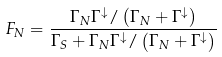Convert formula to latex. <formula><loc_0><loc_0><loc_500><loc_500>F _ { N } = \frac { \Gamma _ { N } \Gamma ^ { \downarrow } / \left ( \Gamma _ { N } + \Gamma ^ { \downarrow } \right ) } { \Gamma _ { S } + \Gamma _ { N } \Gamma ^ { \downarrow } / \left ( \Gamma _ { N } + \Gamma ^ { \downarrow } \right ) }</formula> 